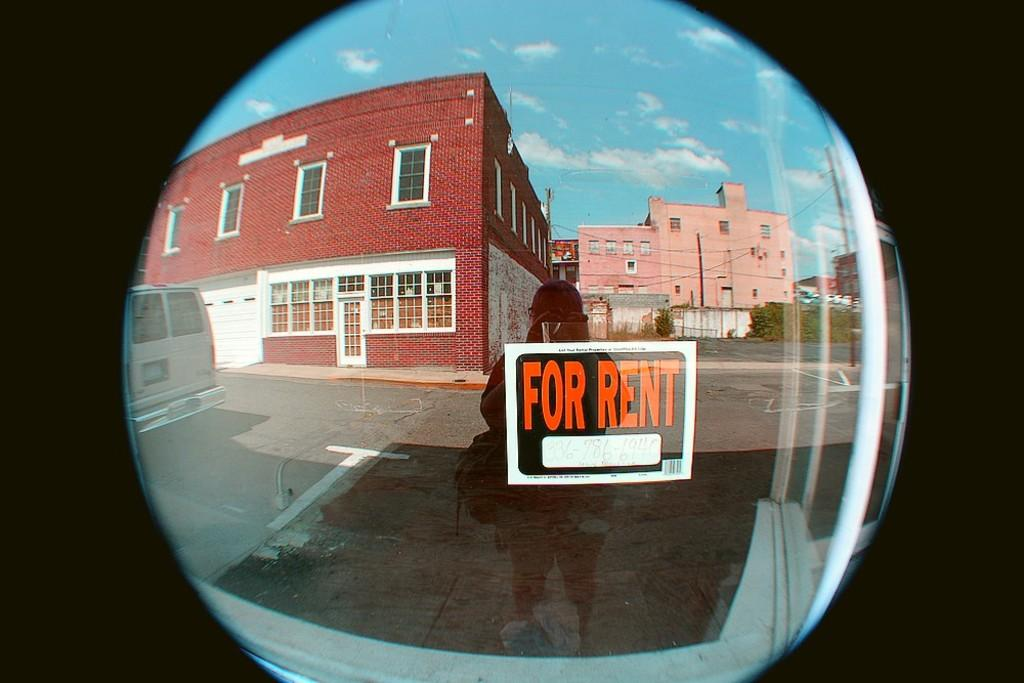<image>
Offer a succinct explanation of the picture presented. A woman looking through a glass door with a For Rent sign hanging on it. 